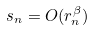Convert formula to latex. <formula><loc_0><loc_0><loc_500><loc_500>s _ { n } = O ( r _ { n } ^ { \beta } )</formula> 